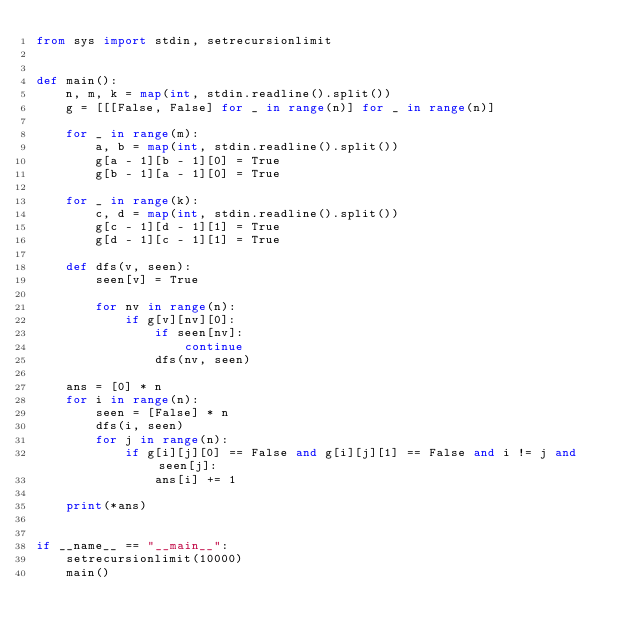Convert code to text. <code><loc_0><loc_0><loc_500><loc_500><_Python_>from sys import stdin, setrecursionlimit


def main():
    n, m, k = map(int, stdin.readline().split())
    g = [[[False, False] for _ in range(n)] for _ in range(n)]

    for _ in range(m):
        a, b = map(int, stdin.readline().split())
        g[a - 1][b - 1][0] = True
        g[b - 1][a - 1][0] = True

    for _ in range(k):
        c, d = map(int, stdin.readline().split())
        g[c - 1][d - 1][1] = True
        g[d - 1][c - 1][1] = True

    def dfs(v, seen):
        seen[v] = True

        for nv in range(n):
            if g[v][nv][0]:
                if seen[nv]:
                    continue
                dfs(nv, seen)

    ans = [0] * n
    for i in range(n):
        seen = [False] * n
        dfs(i, seen)
        for j in range(n):
            if g[i][j][0] == False and g[i][j][1] == False and i != j and seen[j]:
                ans[i] += 1

    print(*ans)


if __name__ == "__main__":
    setrecursionlimit(10000)
    main()</code> 